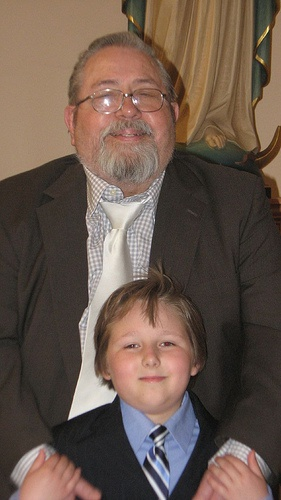Describe the objects in this image and their specific colors. I can see people in gray, black, darkgray, and lightgray tones, people in gray, black, tan, and darkgray tones, tie in gray, lightgray, and darkgray tones, and tie in gray, navy, and darkgray tones in this image. 